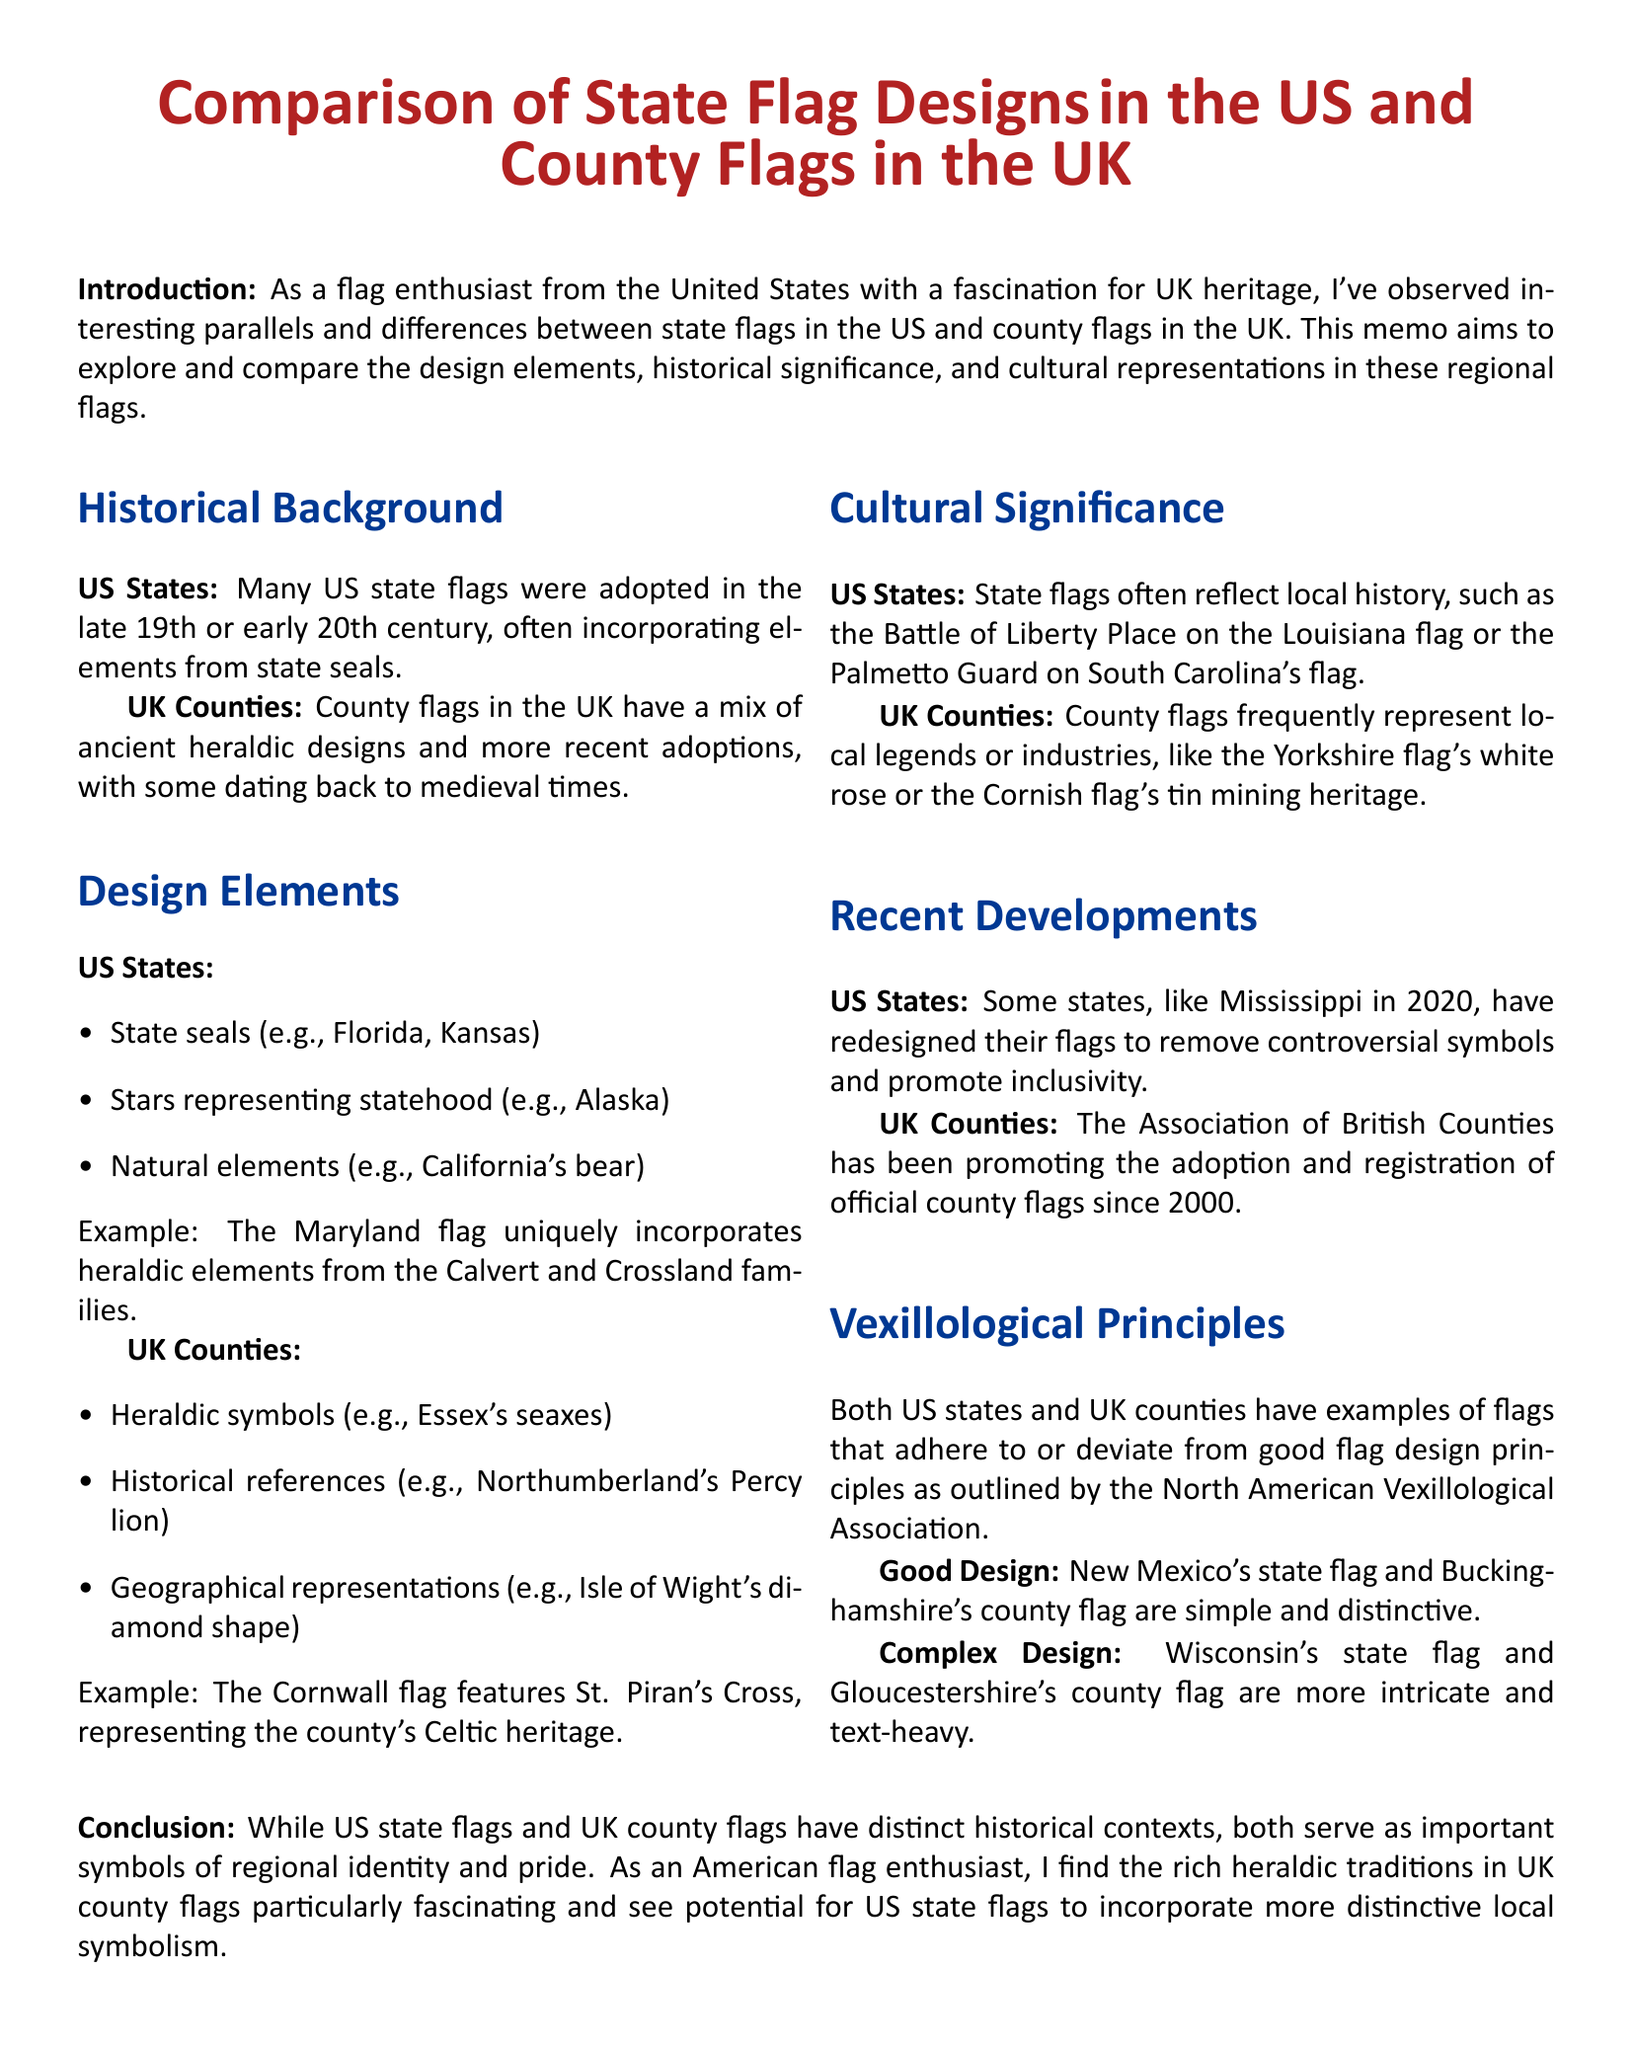What is the main purpose of the memo? The main purpose is to explore and compare design elements, historical significance, and cultural representations in state flags and county flags.
Answer: Explore and compare design elements, historical significance, and cultural representations What year did Mississippi redesign its flag? The document states that Mississippi redesigned its flag in the year 2020.
Answer: 2020 Which flag represents Cornwall's Celtic heritage? The flag that represents Cornwall's Celtic heritage is specifically mentioned as featuring St. Piran's Cross.
Answer: Cornwall flag What are the common features of US state flags? Common features include state seals, stars representing statehood, and natural elements like California's bear.
Answer: State seals, stars, natural elements Which two flags are cited as examples of good design? The example flags for good design mentioned are New Mexico's state flag and Buckinghamshire's county flag.
Answer: New Mexico's state flag and Buckinghamshire's county flag What organization promotes the adoption of official county flags in the UK? The organization mentioned that promotes the adoption of official county flags is the Association of British Counties.
Answer: Association of British Counties How do county flags in the UK reflect local legends? The document explains that county flags frequently represent local legends or industries, as seen with the Yorkshire flag's white rose.
Answer: Local legends or industries What is a notable recent trend regarding US state flags? A notable recent trend is that some states have redesigned their flags to remove controversial symbols and promote inclusivity.
Answer: Removing controversial symbols and promoting inclusivity 